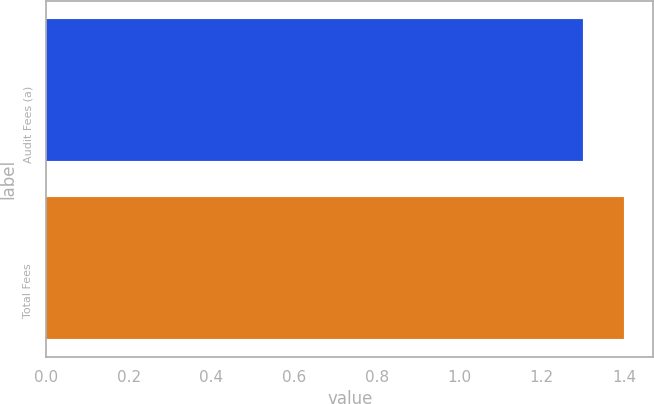Convert chart. <chart><loc_0><loc_0><loc_500><loc_500><bar_chart><fcel>Audit Fees (a)<fcel>Total Fees<nl><fcel>1.3<fcel>1.4<nl></chart> 